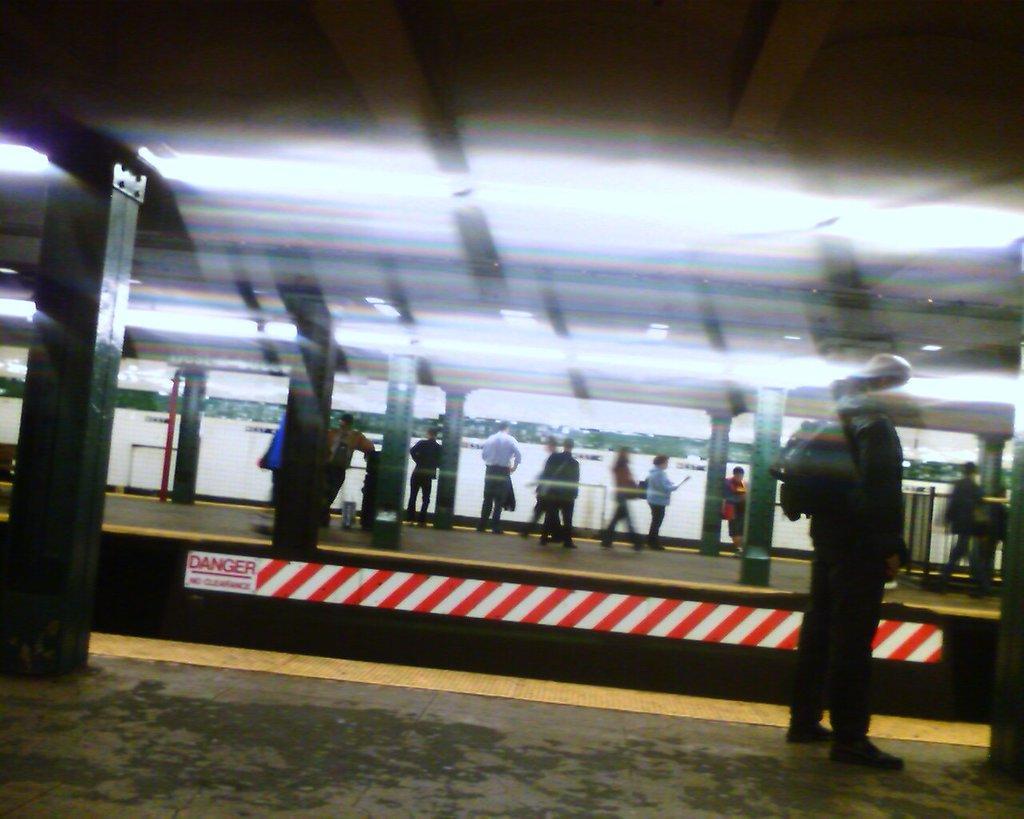In one or two sentences, can you explain what this image depicts? In the image we can see some platforms, on the platforms few people are standing and walking. At the top of the image there are some lights. Background of the image is blur. 